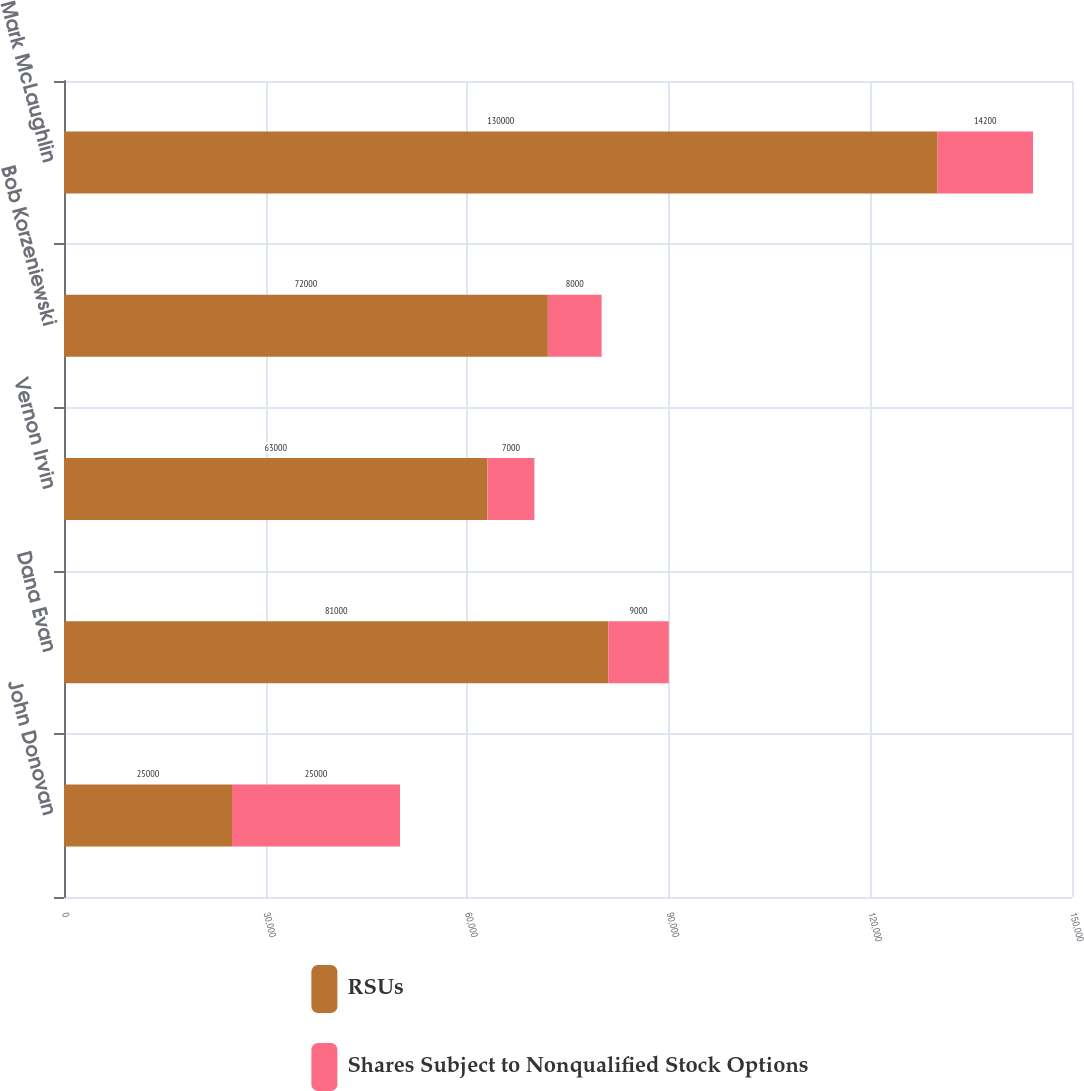Convert chart to OTSL. <chart><loc_0><loc_0><loc_500><loc_500><stacked_bar_chart><ecel><fcel>John Donovan<fcel>Dana Evan<fcel>Vernon Irvin<fcel>Bob Korzeniewski<fcel>Mark McLaughlin<nl><fcel>RSUs<fcel>25000<fcel>81000<fcel>63000<fcel>72000<fcel>130000<nl><fcel>Shares Subject to Nonqualified Stock Options<fcel>25000<fcel>9000<fcel>7000<fcel>8000<fcel>14200<nl></chart> 